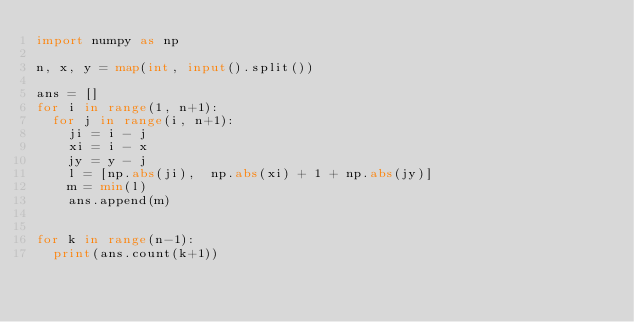<code> <loc_0><loc_0><loc_500><loc_500><_Python_>import numpy as np

n, x, y = map(int, input().split())

ans = []
for i in range(1, n+1):
  for j in range(i, n+1):
    ji = i - j
    xi = i - x
    jy = y - j
    l = [np.abs(ji),  np.abs(xi) + 1 + np.abs(jy)]
    m = min(l)
    ans.append(m)
      
    
for k in range(n-1):
  print(ans.count(k+1))
</code> 